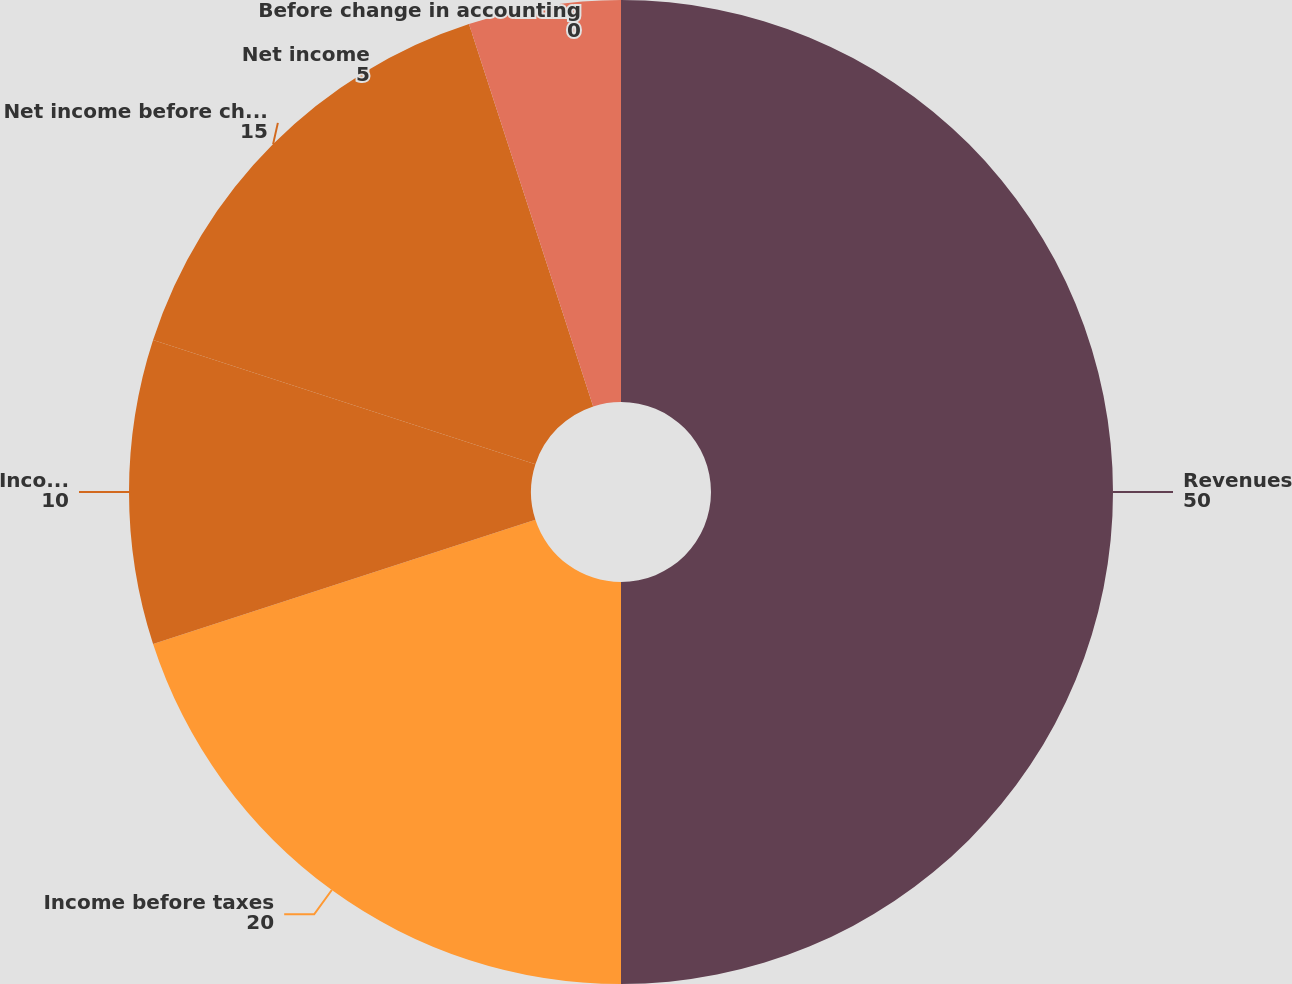<chart> <loc_0><loc_0><loc_500><loc_500><pie_chart><fcel>Revenues<fcel>Income before taxes<fcel>Income taxes<fcel>Net income before change in<fcel>Net income<fcel>Before change in accounting<nl><fcel>50.0%<fcel>20.0%<fcel>10.0%<fcel>15.0%<fcel>5.0%<fcel>0.0%<nl></chart> 